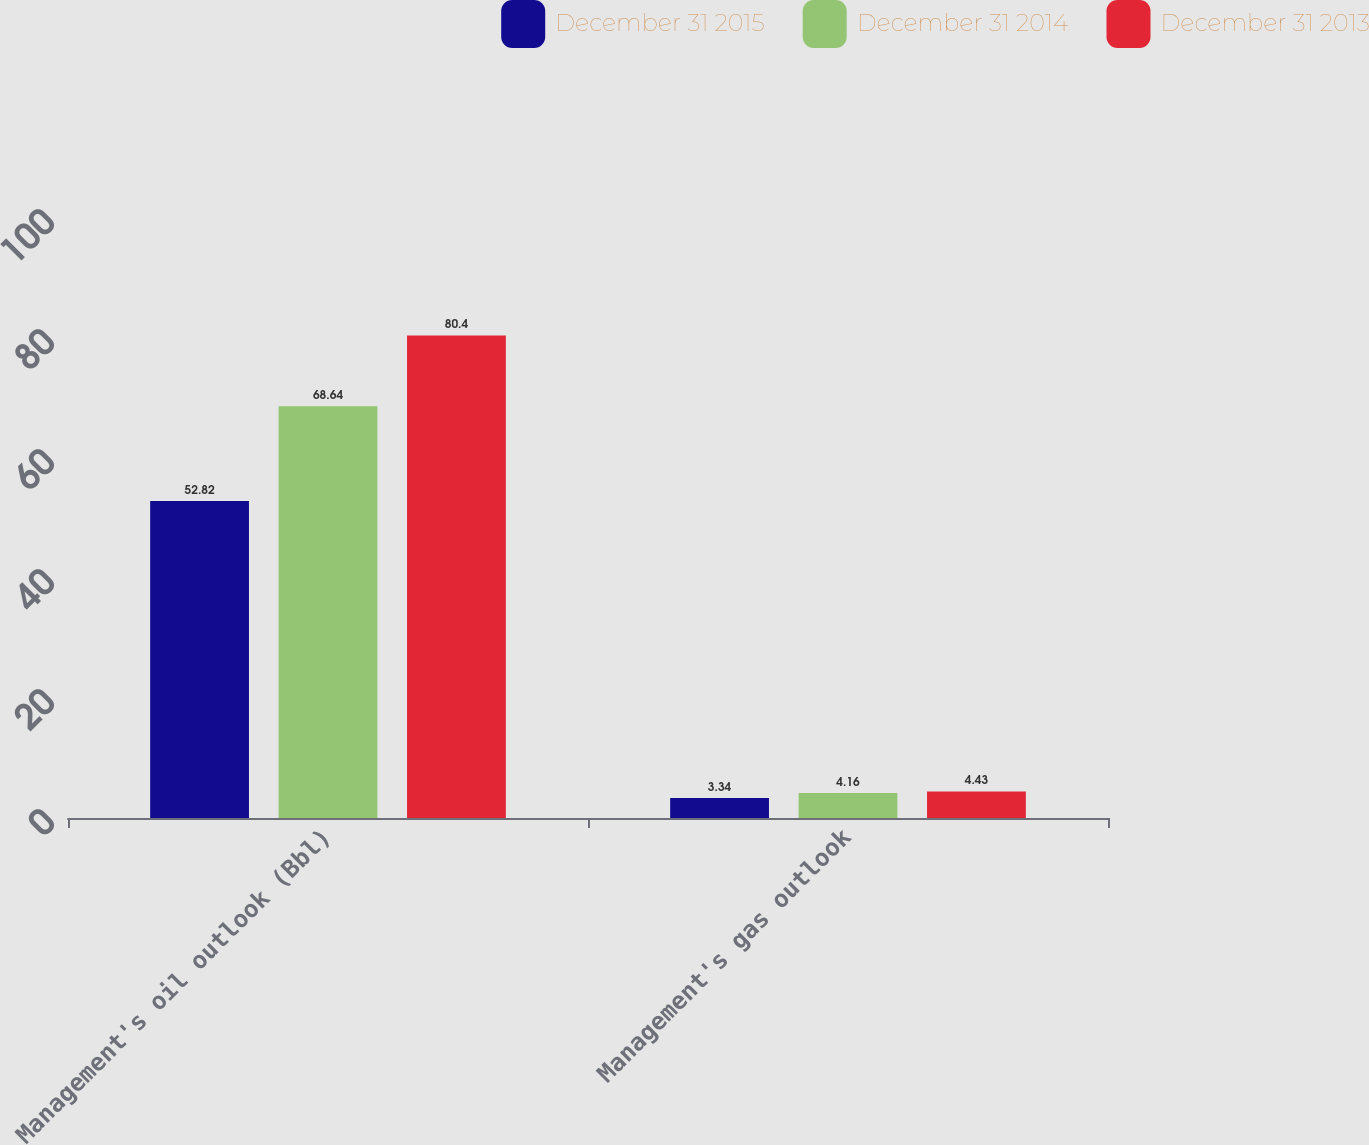<chart> <loc_0><loc_0><loc_500><loc_500><stacked_bar_chart><ecel><fcel>Management's oil outlook (Bbl)<fcel>Management's gas outlook<nl><fcel>December 31 2015<fcel>52.82<fcel>3.34<nl><fcel>December 31 2014<fcel>68.64<fcel>4.16<nl><fcel>December 31 2013<fcel>80.4<fcel>4.43<nl></chart> 